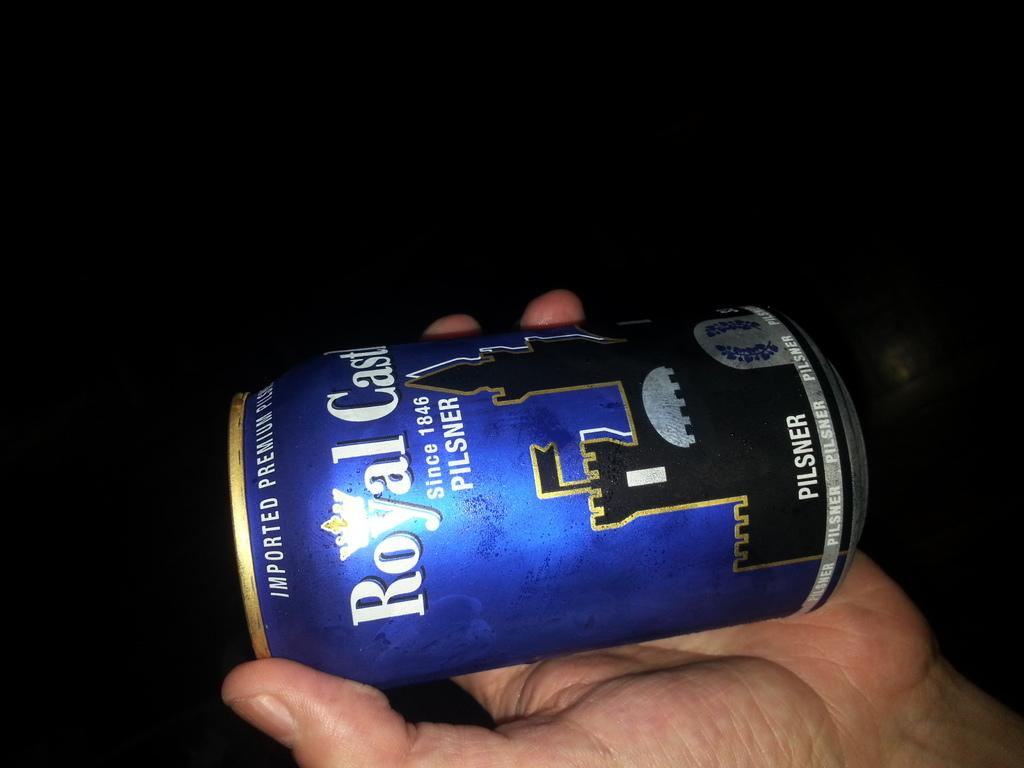<image>
Describe the image concisely. Person holding a blue can which says "Royal Castle" on it. 